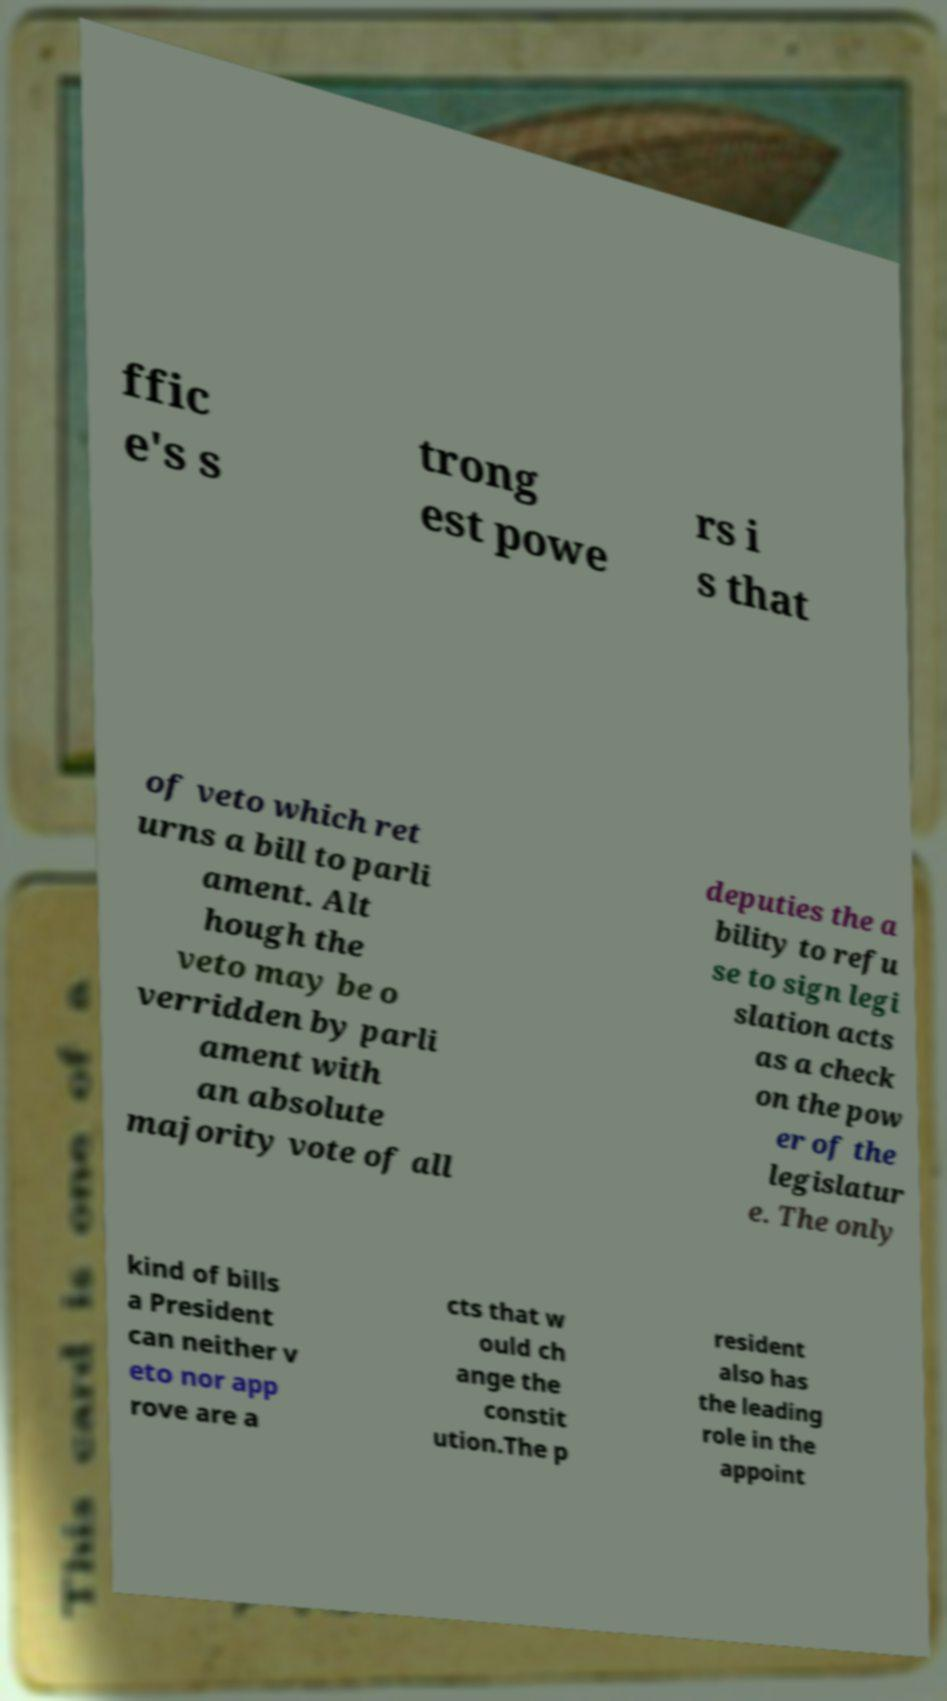Could you extract and type out the text from this image? ffic e's s trong est powe rs i s that of veto which ret urns a bill to parli ament. Alt hough the veto may be o verridden by parli ament with an absolute majority vote of all deputies the a bility to refu se to sign legi slation acts as a check on the pow er of the legislatur e. The only kind of bills a President can neither v eto nor app rove are a cts that w ould ch ange the constit ution.The p resident also has the leading role in the appoint 